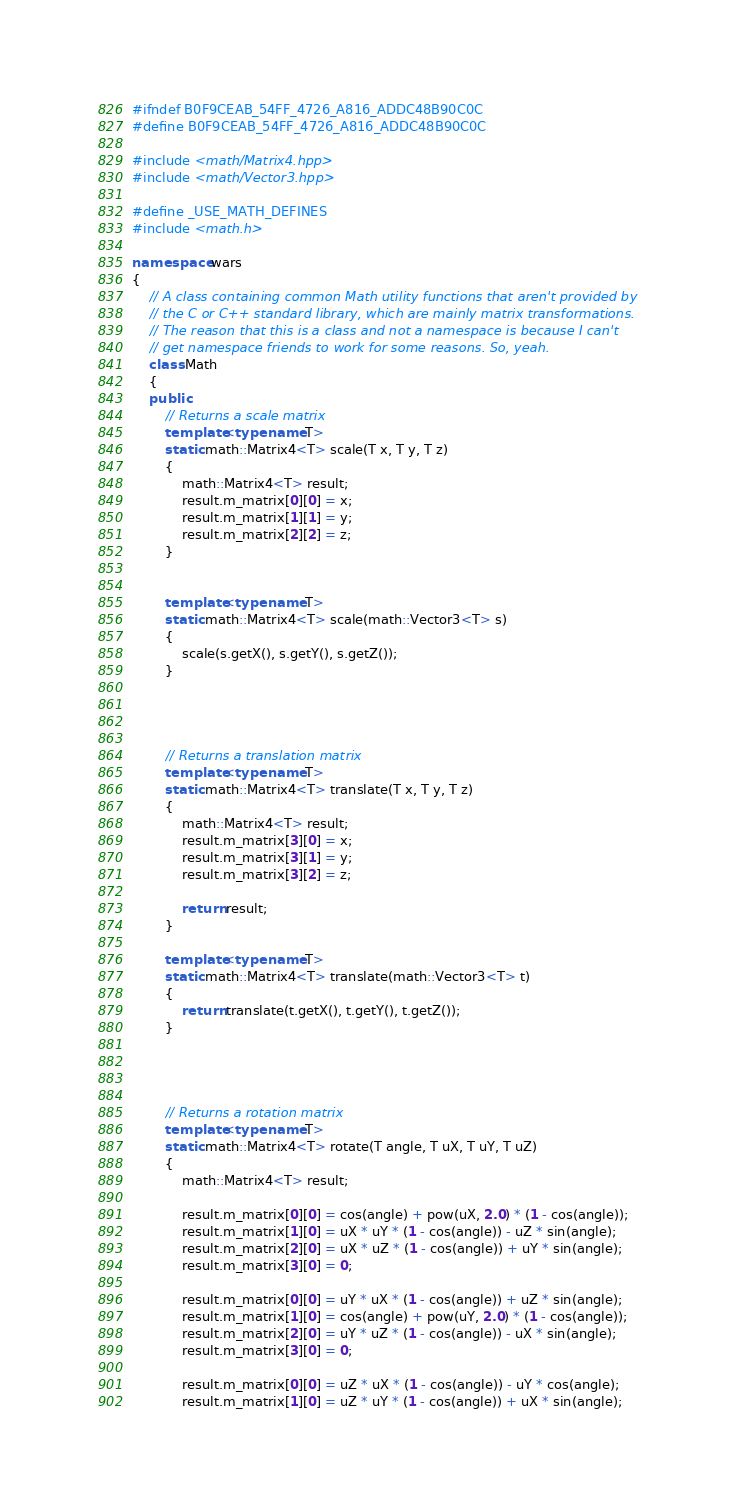<code> <loc_0><loc_0><loc_500><loc_500><_C++_>#ifndef B0F9CEAB_54FF_4726_A816_ADDC48B90C0C
#define B0F9CEAB_54FF_4726_A816_ADDC48B90C0C

#include <math/Matrix4.hpp>
#include <math/Vector3.hpp>

#define _USE_MATH_DEFINES
#include <math.h>

namespace wars
{
    // A class containing common Math utility functions that aren't provided by
    // the C or C++ standard library, which are mainly matrix transformations.
    // The reason that this is a class and not a namespace is because I can't 
    // get namespace friends to work for some reasons. So, yeah.
    class Math
    {
    public:
        // Returns a scale matrix
        template<typename T>
        static math::Matrix4<T> scale(T x, T y, T z)
        {
            math::Matrix4<T> result;
            result.m_matrix[0][0] = x;
            result.m_matrix[1][1] = y;
            result.m_matrix[2][2] = z;
        }
        
        
        template<typename T>
        static math::Matrix4<T> scale(math::Vector3<T> s)
        {
            scale(s.getX(), s.getY(), s.getZ());
        }
        
        
        
        
        // Returns a translation matrix
        template<typename T>
        static math::Matrix4<T> translate(T x, T y, T z)
        {
            math::Matrix4<T> result;
            result.m_matrix[3][0] = x;
            result.m_matrix[3][1] = y;
            result.m_matrix[3][2] = z;
            
            return result;
        }
        
        template<typename T>
        static math::Matrix4<T> translate(math::Vector3<T> t)
        {
            return translate(t.getX(), t.getY(), t.getZ());
        }
        
        
        
        
        // Returns a rotation matrix
        template<typename T>
        static math::Matrix4<T> rotate(T angle, T uX, T uY, T uZ)
        {
            math::Matrix4<T> result;
            
            result.m_matrix[0][0] = cos(angle) + pow(uX, 2.0) * (1 - cos(angle));
            result.m_matrix[1][0] = uX * uY * (1 - cos(angle)) - uZ * sin(angle);
            result.m_matrix[2][0] = uX * uZ * (1 - cos(angle)) + uY * sin(angle);
            result.m_matrix[3][0] = 0;
            
            result.m_matrix[0][0] = uY * uX * (1 - cos(angle)) + uZ * sin(angle);
            result.m_matrix[1][0] = cos(angle) + pow(uY, 2.0) * (1 - cos(angle));
            result.m_matrix[2][0] = uY * uZ * (1 - cos(angle)) - uX * sin(angle);
            result.m_matrix[3][0] = 0;
            
            result.m_matrix[0][0] = uZ * uX * (1 - cos(angle)) - uY * cos(angle);
            result.m_matrix[1][0] = uZ * uY * (1 - cos(angle)) + uX * sin(angle);</code> 